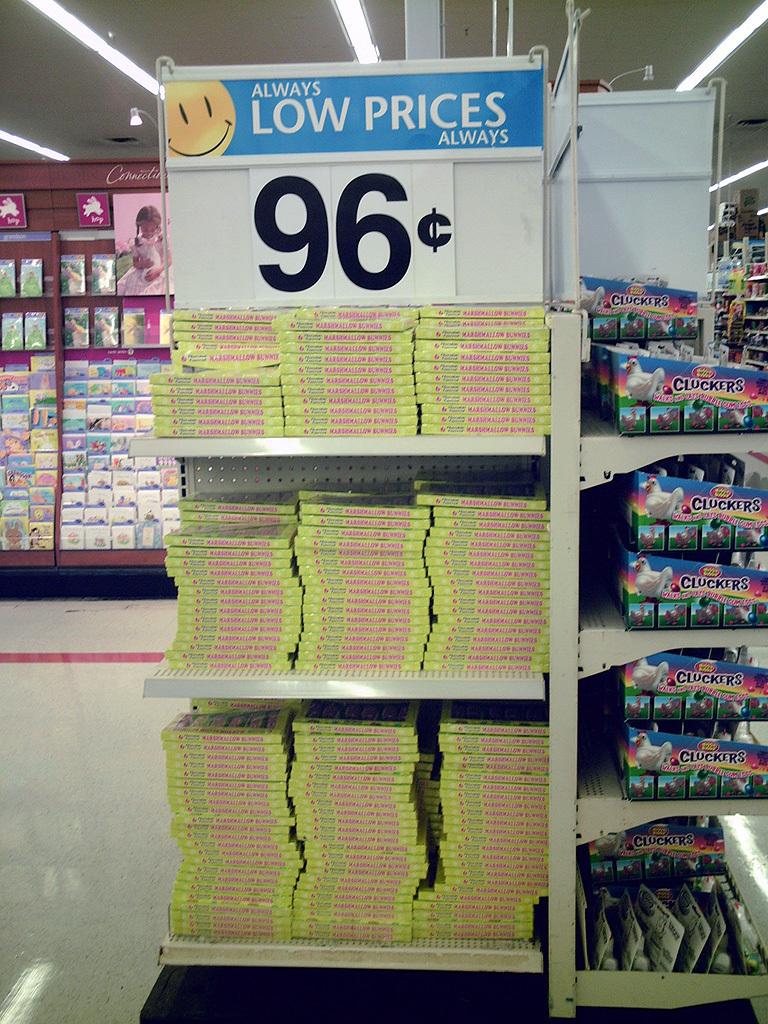What is the price of the product shown?
Your response must be concise. 96 cents. What is there always according to the sign?
Offer a terse response. Low prices. 